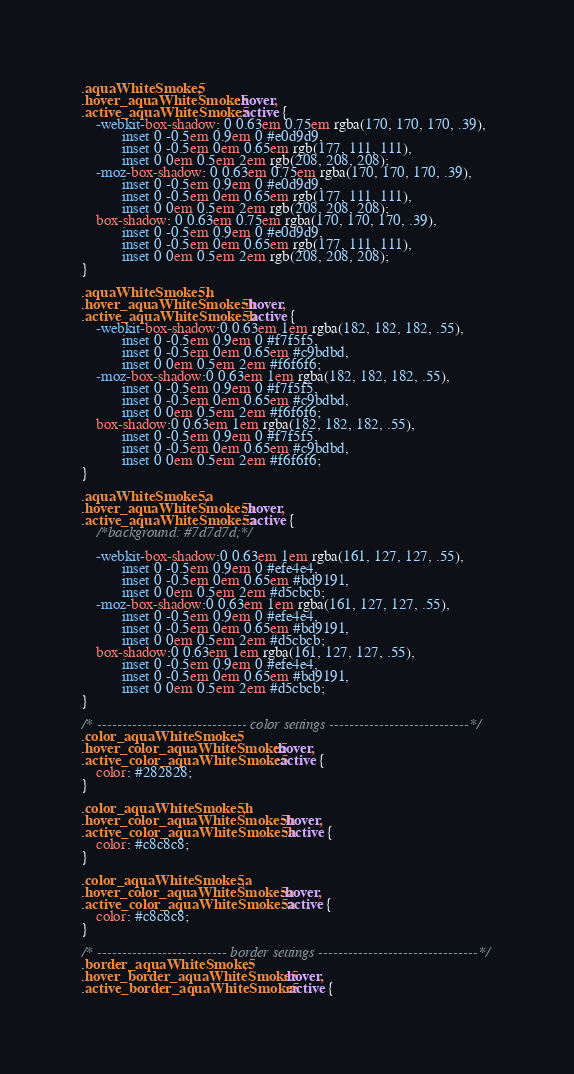<code> <loc_0><loc_0><loc_500><loc_500><_CSS_>.aquaWhiteSmoke5,
.hover_aquaWhiteSmoke5:hover,
.active_aquaWhiteSmoke5:active {
    -webkit-box-shadow: 0 0.63em 0.75em rgba(170, 170, 170, .39),
           inset 0 -0.5em 0.9em 0 #e0d9d9,
           inset 0 -0.5em 0em 0.65em rgb(177, 111, 111),
           inset 0 0em 0.5em 2em rgb(208, 208, 208);
    -moz-box-shadow: 0 0.63em 0.75em rgba(170, 170, 170, .39),
           inset 0 -0.5em 0.9em 0 #e0d9d9,
           inset 0 -0.5em 0em 0.65em rgb(177, 111, 111),
           inset 0 0em 0.5em 2em rgb(208, 208, 208);
    box-shadow: 0 0.63em 0.75em rgba(170, 170, 170, .39),
           inset 0 -0.5em 0.9em 0 #e0d9d9,
           inset 0 -0.5em 0em 0.65em rgb(177, 111, 111),
           inset 0 0em 0.5em 2em rgb(208, 208, 208);
}

.aquaWhiteSmoke5h,
.hover_aquaWhiteSmoke5h:hover,
.active_aquaWhiteSmoke5h:active {
    -webkit-box-shadow:0 0.63em 1em rgba(182, 182, 182, .55),
           inset 0 -0.5em 0.9em 0 #f7f5f5,
           inset 0 -0.5em 0em 0.65em #c9bdbd,
           inset 0 0em 0.5em 2em #f6f6f6;
    -moz-box-shadow:0 0.63em 1em rgba(182, 182, 182, .55),
           inset 0 -0.5em 0.9em 0 #f7f5f5,
           inset 0 -0.5em 0em 0.65em #c9bdbd,
           inset 0 0em 0.5em 2em #f6f6f6;
    box-shadow:0 0.63em 1em rgba(182, 182, 182, .55),
           inset 0 -0.5em 0.9em 0 #f7f5f5,
           inset 0 -0.5em 0em 0.65em #c9bdbd,
           inset 0 0em 0.5em 2em #f6f6f6;
}

.aquaWhiteSmoke5a,
.hover_aquaWhiteSmoke5a:hover,
.active_aquaWhiteSmoke5a:active {
    /*background: #7d7d7d;*/

    -webkit-box-shadow:0 0.63em 1em rgba(161, 127, 127, .55),
           inset 0 -0.5em 0.9em 0 #efe4e4,
           inset 0 -0.5em 0em 0.65em #bd9191,
           inset 0 0em 0.5em 2em #d5cbcb;
    -moz-box-shadow:0 0.63em 1em rgba(161, 127, 127, .55),
           inset 0 -0.5em 0.9em 0 #efe4e4,
           inset 0 -0.5em 0em 0.65em #bd9191,
           inset 0 0em 0.5em 2em #d5cbcb;
    box-shadow:0 0.63em 1em rgba(161, 127, 127, .55),
           inset 0 -0.5em 0.9em 0 #efe4e4,
           inset 0 -0.5em 0em 0.65em #bd9191,
           inset 0 0em 0.5em 2em #d5cbcb;
}

/* ------------------------------ color settings ----------------------------*/
.color_aquaWhiteSmoke5,
.hover_color_aquaWhiteSmoke5:hover,
.active_color_aquaWhiteSmoke5:active {
    color: #282828;
}

.color_aquaWhiteSmoke5h,
.hover_color_aquaWhiteSmoke5h:hover,
.active_color_aquaWhiteSmoke5h:active {
    color: #c8c8c8;
}

.color_aquaWhiteSmoke5a,
.hover_color_aquaWhiteSmoke5a:hover,
.active_color_aquaWhiteSmoke5a:active {
    color: #c8c8c8;
}

/* -------------------------- border settings --------------------------------*/
.border_aquaWhiteSmoke5,
.hover_border_aquaWhiteSmoke5:hover,
.active_border_aquaWhiteSmoke5:active {</code> 